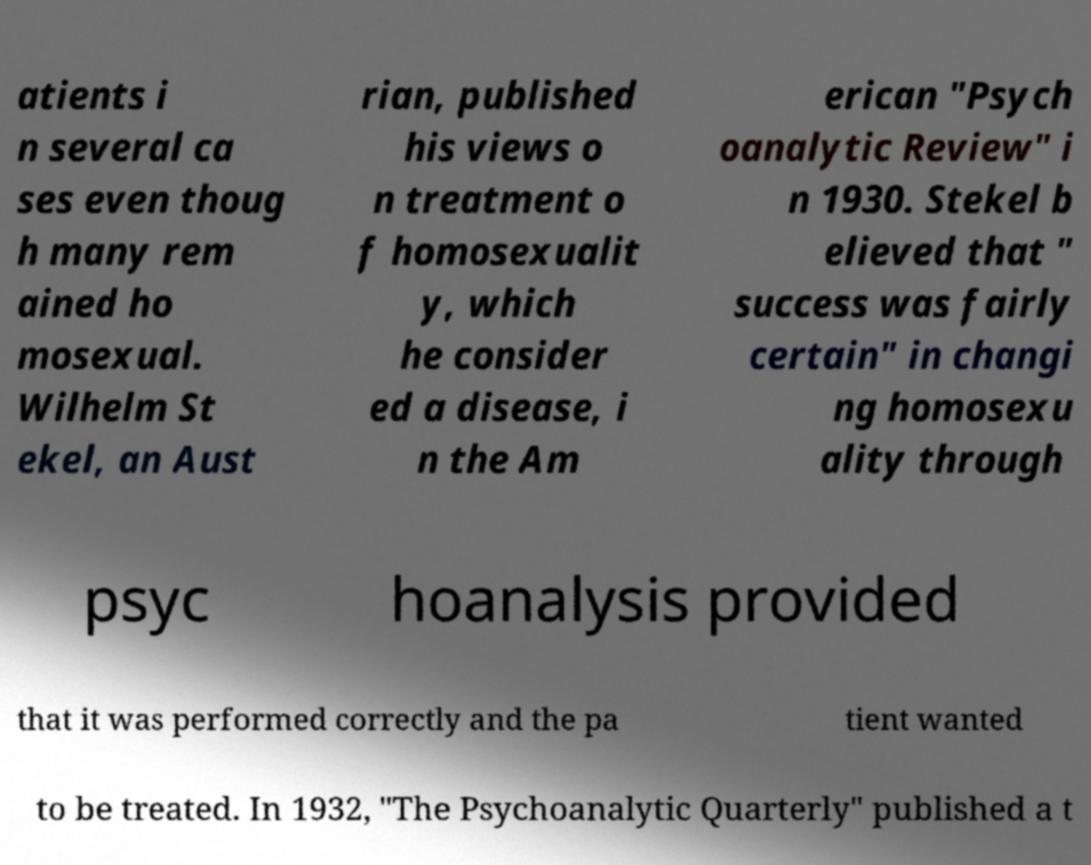There's text embedded in this image that I need extracted. Can you transcribe it verbatim? atients i n several ca ses even thoug h many rem ained ho mosexual. Wilhelm St ekel, an Aust rian, published his views o n treatment o f homosexualit y, which he consider ed a disease, i n the Am erican "Psych oanalytic Review" i n 1930. Stekel b elieved that " success was fairly certain" in changi ng homosexu ality through psyc hoanalysis provided that it was performed correctly and the pa tient wanted to be treated. In 1932, "The Psychoanalytic Quarterly" published a t 